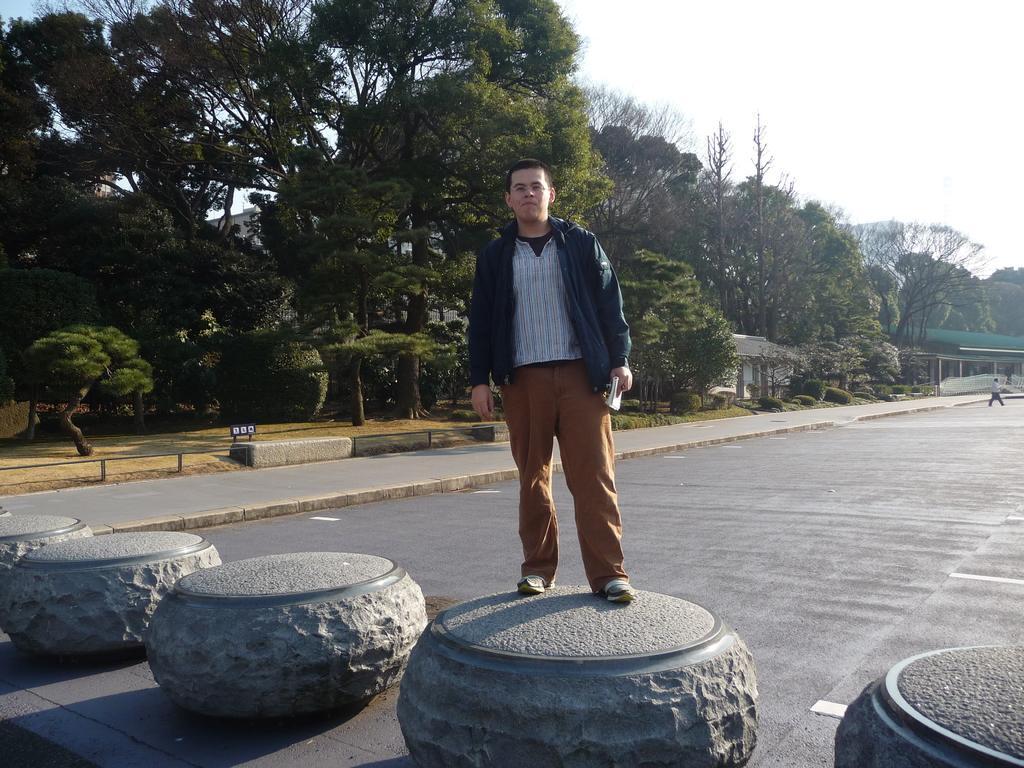Could you give a brief overview of what you see in this image? In this image we can see a person standing on a concrete stand. We can also see a person walking on the road. On the backside we can see some trees, a house with a roof and the sky. 